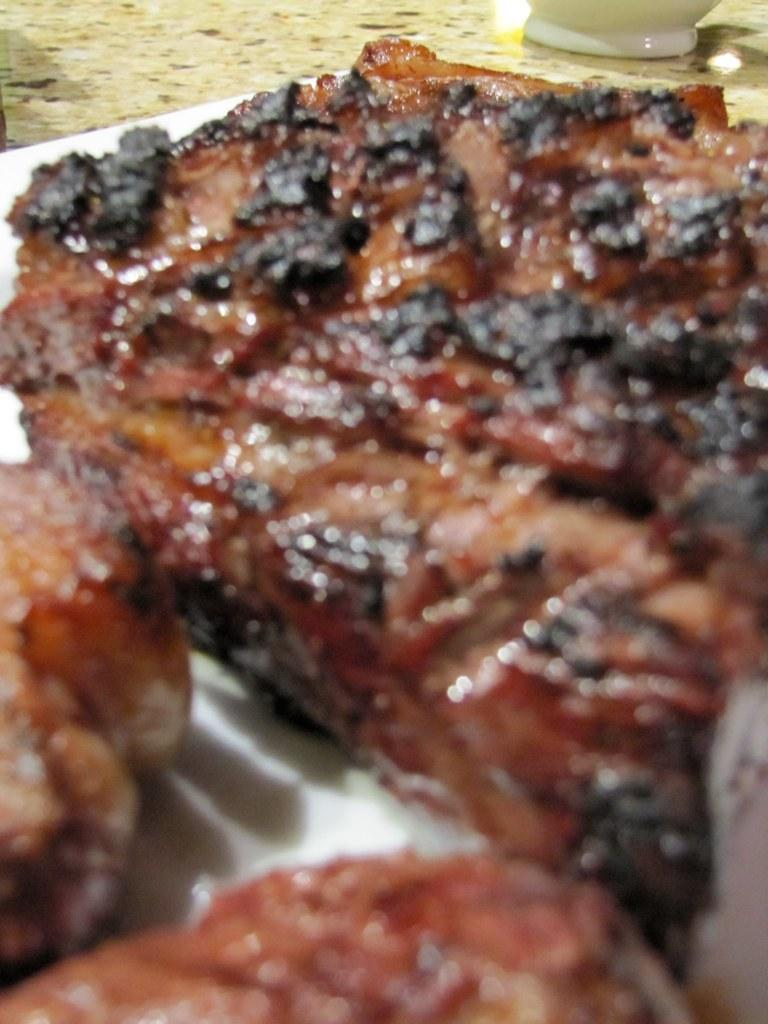What type of food is on the plate in the image? There is grilled meat on a plate in the image. What brand of toothpaste is being advertised in the image? There is no toothpaste or advertisement present in the image; it features a plate with grilled meat. What type of protest is taking place in the image? There is no protest or any indication of a protest in the image; it features a plate with grilled meat. 